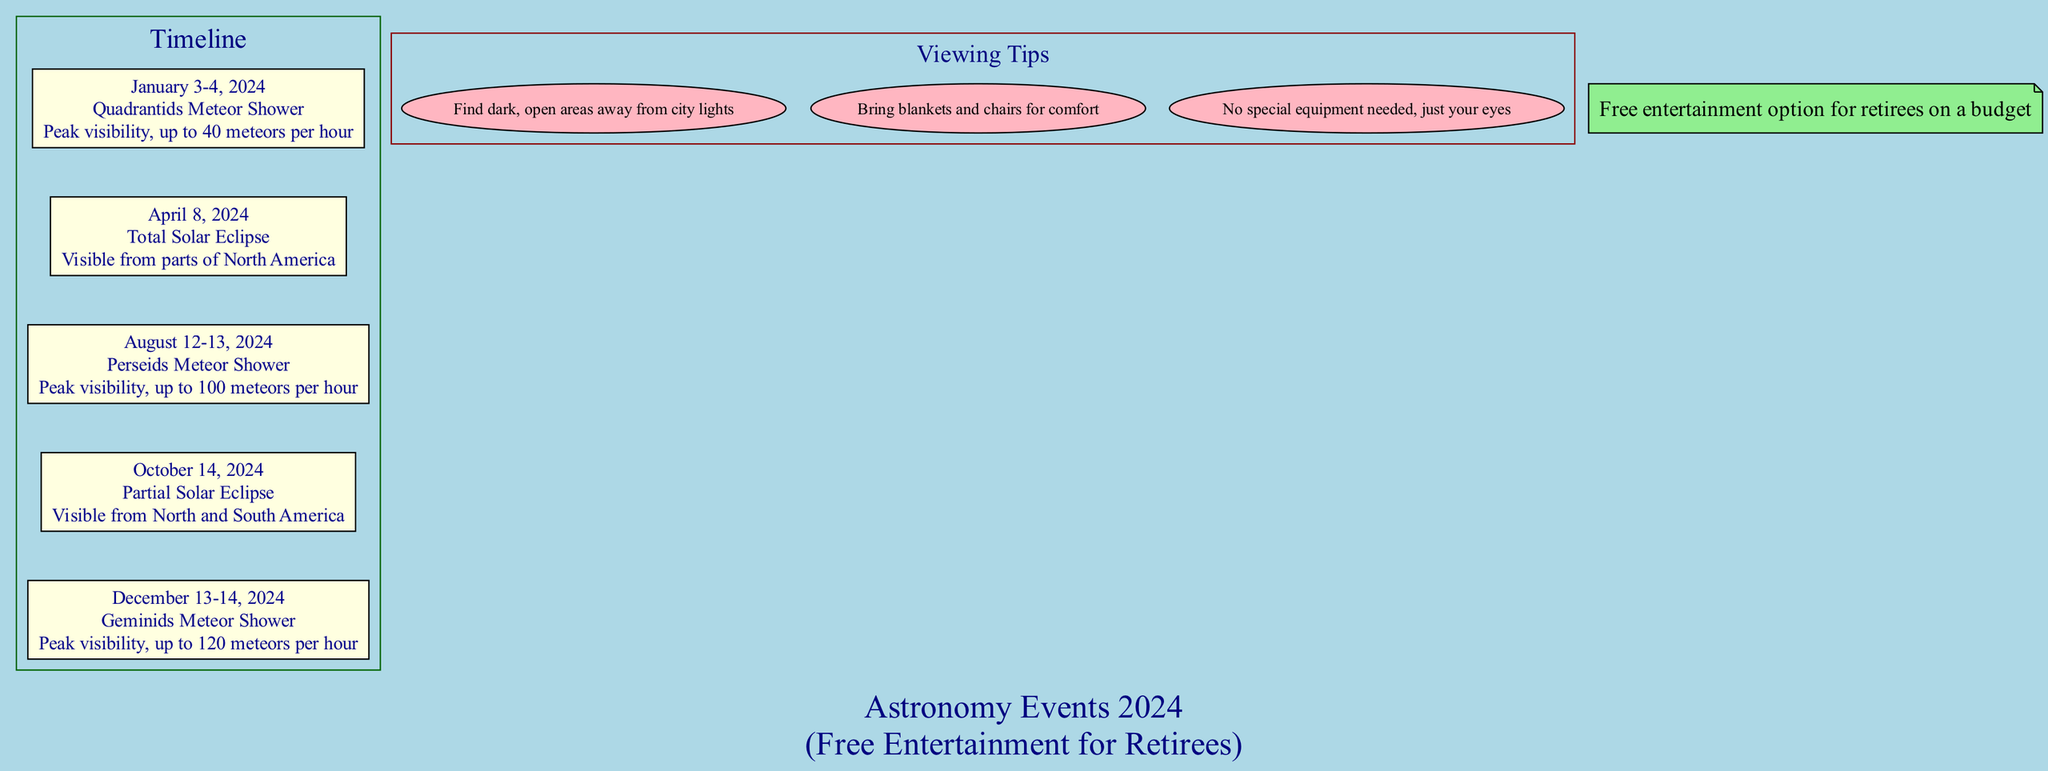What events occur on January 3-4, 2024? The diagram indicates that on these dates, the Quadrantids Meteor Shower occurs, with a description stating "Peak visibility, up to 40 meteors per hour."
Answer: Quadrantids Meteor Shower How many meteors per hour can be seen during the Perseids Meteor Shower? According to the diagram, the Perseids Meteor Shower, which occurs on August 12-13, 2024, has a peak visibility of "up to 100 meteors per hour."
Answer: 100 meteors per hour What is the date of the Total Solar Eclipse? The diagram lists the Total Solar Eclipse event on April 8, 2024, indicating when it will occur.
Answer: April 8, 2024 Which meteor shower has the highest peak visibility? Upon examining the diagram, the Geminids Meteor Shower, set for December 13-14, 2024, states a peak visibility of "up to 120 meteors per hour," making it the highest.
Answer: Geminids Meteor Shower What color indicates the Viewing Tips section? The diagram highlights the Viewing Tips section with the color "dark red."
Answer: Dark red How many viewing tips are shown in the diagram? By counting the nodes under the Viewing Tips section in the diagram, there are three distinct tips provided.
Answer: 3 What are the dates for the Gemenids Meteor Shower? The diagram specifies the dates for the Geminids Meteor Shower as December 13-14, 2024.
Answer: December 13-14, 2024 What is a recommended action for watching astronomical events according to the viewing tips? One of the viewing tips encourages finding "dark, open areas away from city lights," which is a recommended action for viewing events.
Answer: Find dark, open areas away from city lights Which event is considered free entertainment for retirees on a budget? The entire timeline of events is noted in the diagram as a "Free entertainment option for retirees on a budget," indicating that all listed events can be enjoyed without cost.
Answer: Free entertainment option for retirees on a budget 